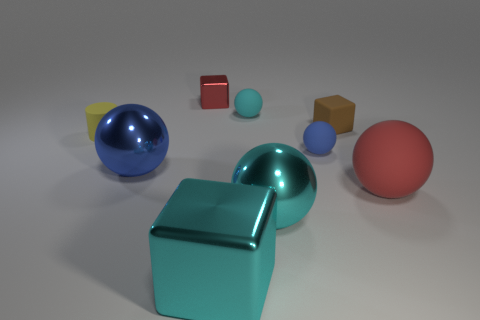If this image were part of a sequence, what do you think might happen next? If part of a sequence, it's possible the next image could show movement or interaction among the objects, such as one of the spheres rolling towards the cube or perhaps a new object being introduced, changing the dynamics of the composition. 